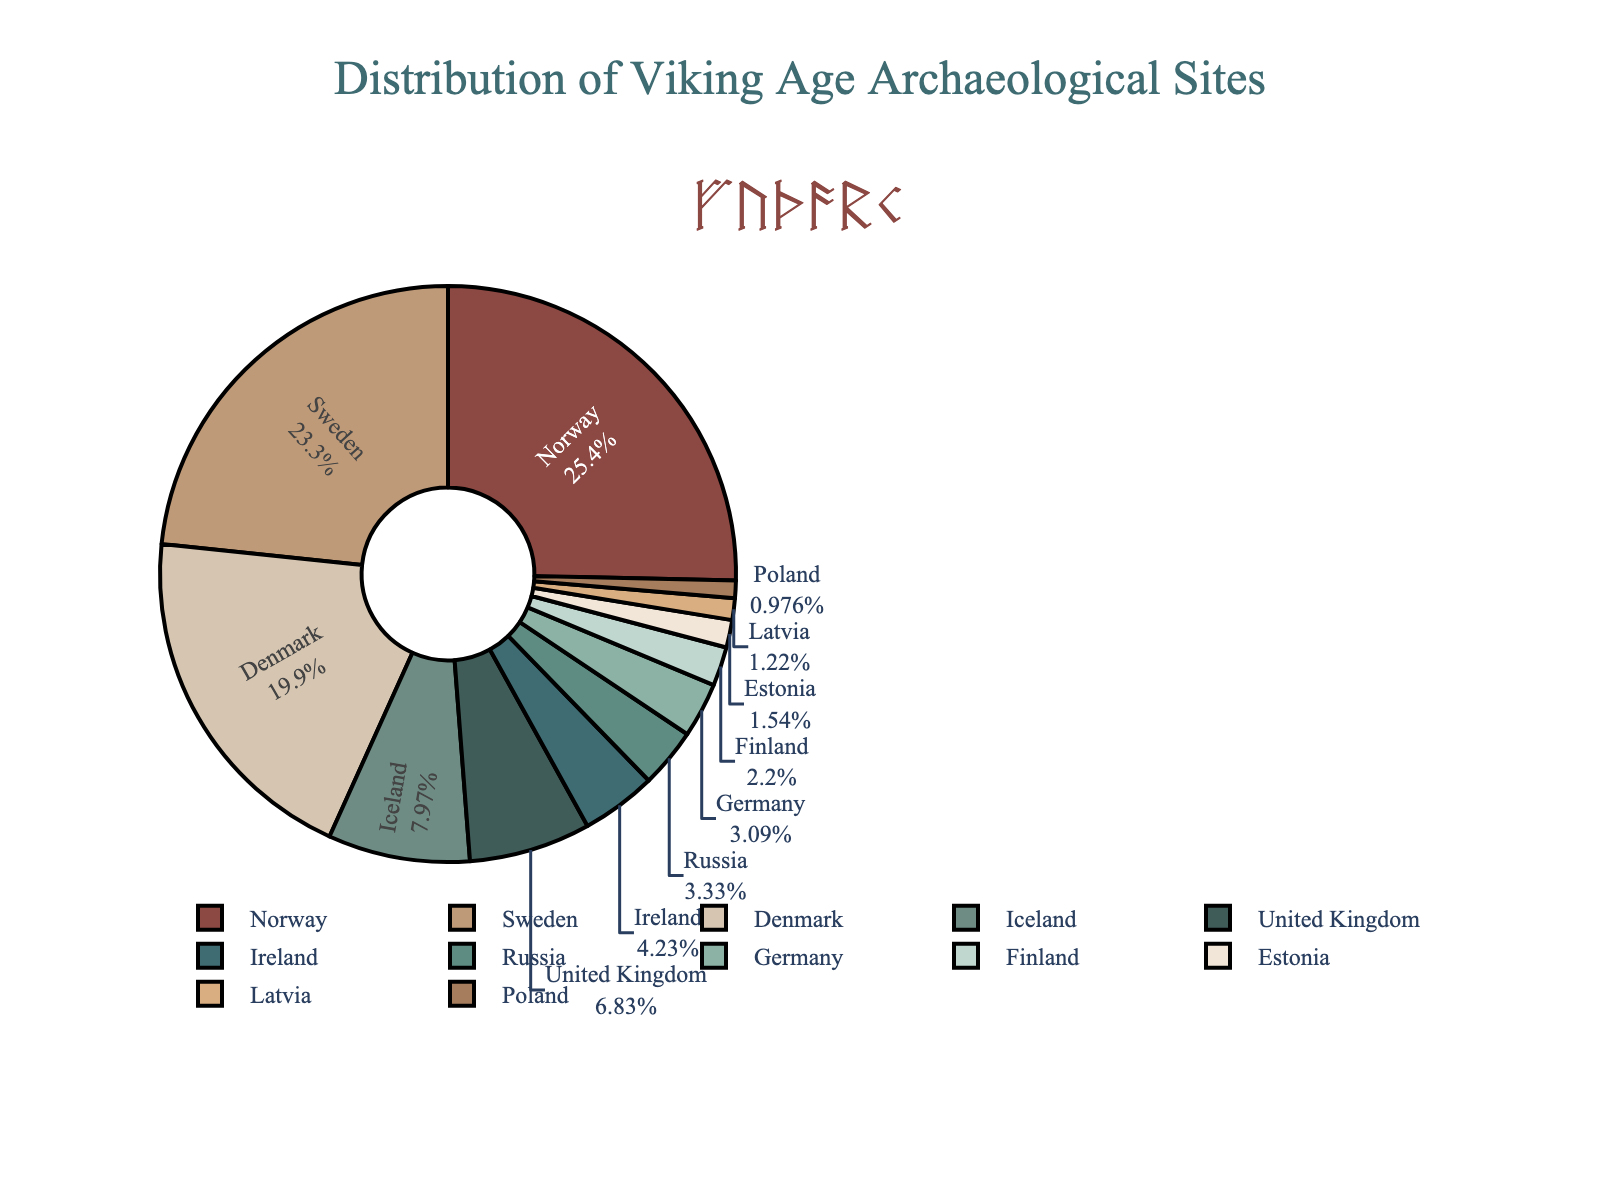Which country has the highest number of Viking Age archaeological sites? Norway has the highest number of sites as indicated by the largest slice of the pie chart.
Answer: Norway Which country has fewer Viking Age sites, Denmark or Iceland? The pie chart shows that Denmark has a larger slice than Iceland, indicating Denmark has more sites.
Answer: Iceland Approximately what percentage of the total sites are found in Sweden? The pie chart shows Sweden's slice is labeled with its percentage of the total sites. By reading the label, Sweden has around 24.7% of the sites.
Answer: 24.7% How many more Viking Age sites does Norway have compared to Ireland? Norway has 312 sites while Ireland has 52. The difference is 312 - 52.
Answer: 260 What is the combined total of Viking Age sites in Germany and Finland? According to the pie chart, Germany has 38 sites and Finland has 27. Their combined total is 38 + 27.
Answer: 65 Which has a larger number of sites, Russia or the United Kingdom? The pie chart shows the slice for the United Kingdom is larger than that for Russia, indicating the UK has more sites.
Answer: United Kingdom What is the percentage of Viking Age sites found in Denmark and Iceland combined? Add the percentages for Denmark and Iceland from the pie chart. Denmark is 21.1% and Iceland is 8.4%. The combined percentage is 21.1 + 8.4.
Answer: 29.5% If you grouped the countries with fewer than 50 sites into one category, what new percentage would this group represent? Add the number of sites for countries with fewer than 50 (Ireland, Russia, Germany, Finland, Estonia, Latvia, and Poland). Total = 52+41+38+27+19+15+12 = 204. The combined number of sites is 1230. The percentage is (204/1230)*100.
Answer: 16.6% Between Norway and Sweden, which country has a closer percentage to 25% of the total sites? Norway has 25.4% and Sweden has 23.4% according to the pie chart. Norway is closer to 25%.
Answer: Norway By how much does the number of sites in Estonia exceed the number in Latvia? Estonia has 19 sites and Latvia has 15, so Estonia exceeds Latvia by 19 - 15.
Answer: 4 